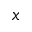Convert formula to latex. <formula><loc_0><loc_0><loc_500><loc_500>x</formula> 